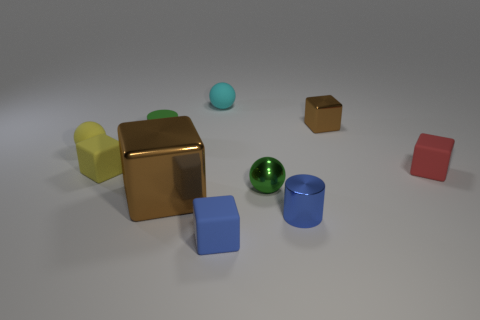Subtract all red blocks. How many blocks are left? 4 Subtract all big metallic blocks. How many blocks are left? 4 Subtract all blue cubes. Subtract all yellow balls. How many cubes are left? 4 Subtract all balls. How many objects are left? 7 Add 3 yellow rubber objects. How many yellow rubber objects are left? 5 Add 2 large brown matte objects. How many large brown matte objects exist? 2 Subtract 0 purple cubes. How many objects are left? 10 Subtract all tiny green matte cylinders. Subtract all gray balls. How many objects are left? 9 